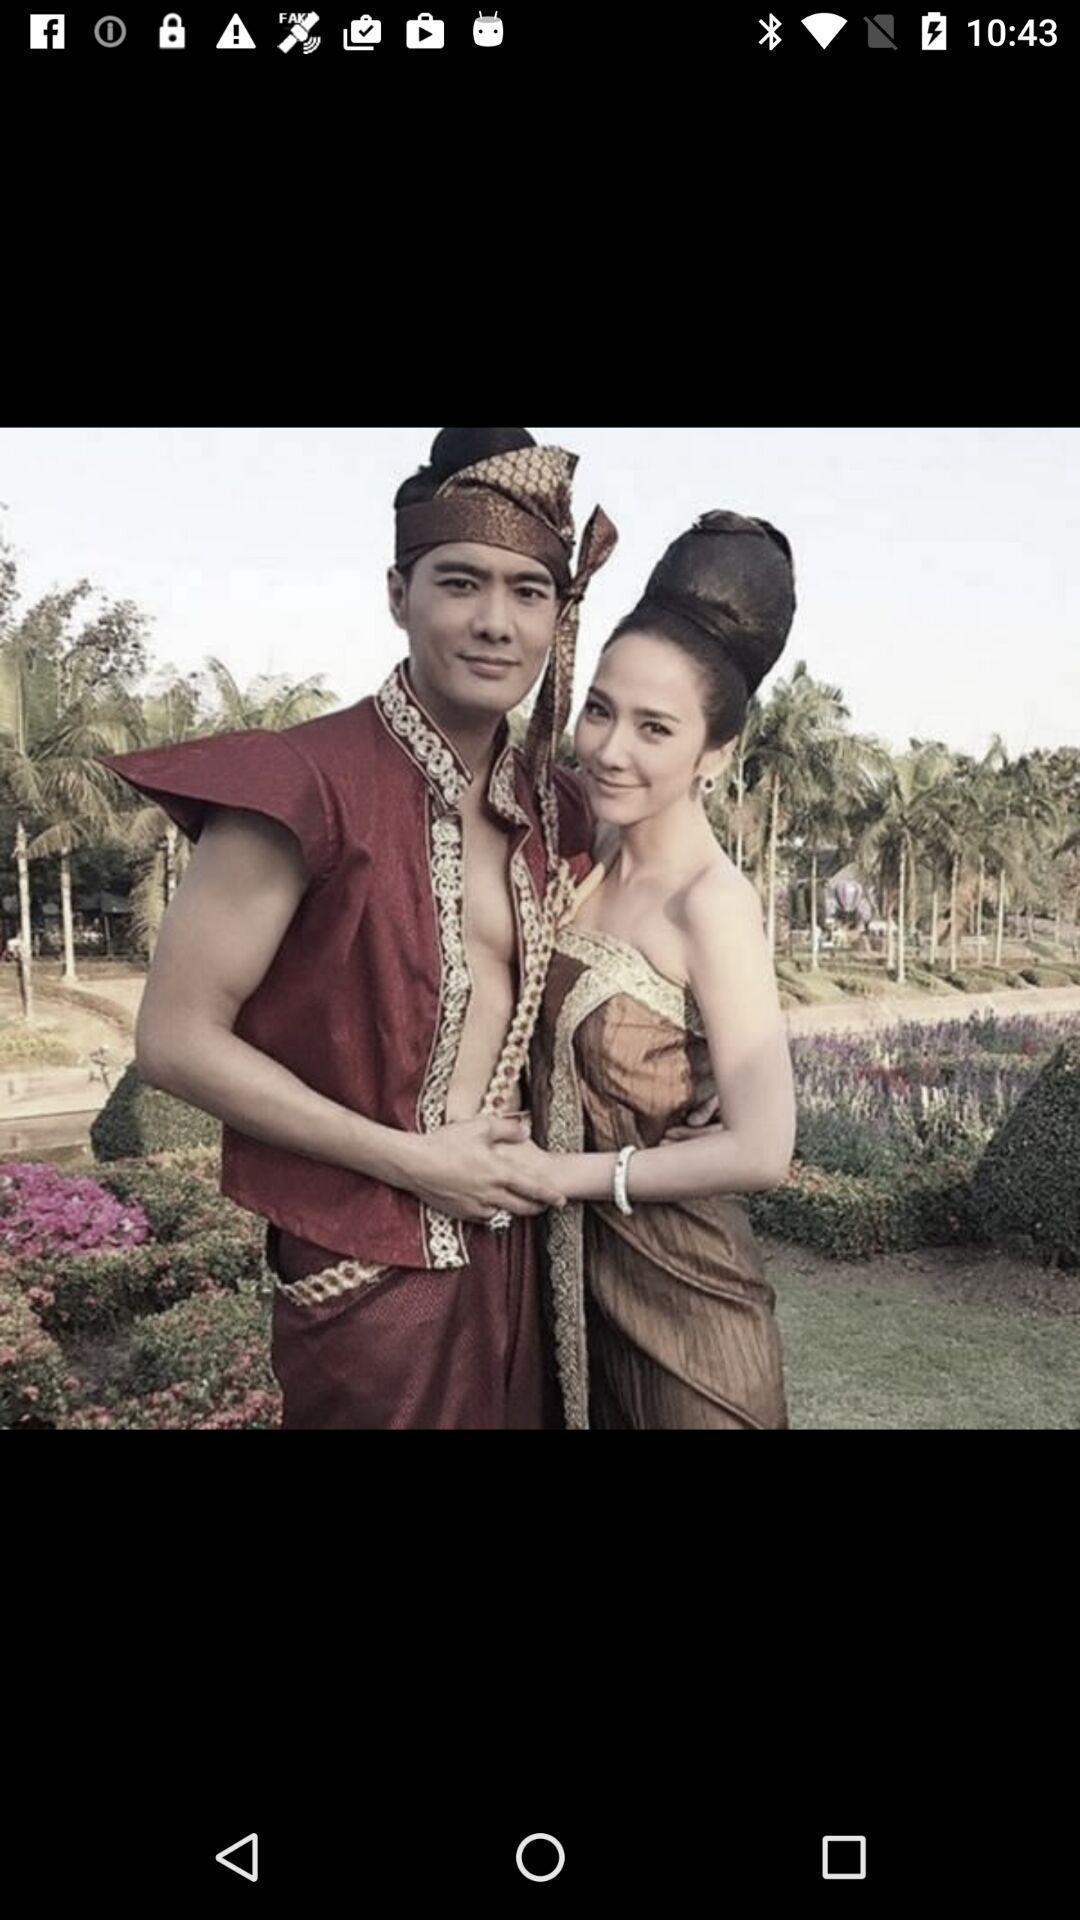Provide a textual representation of this image. Page displaying image in gallery app. 